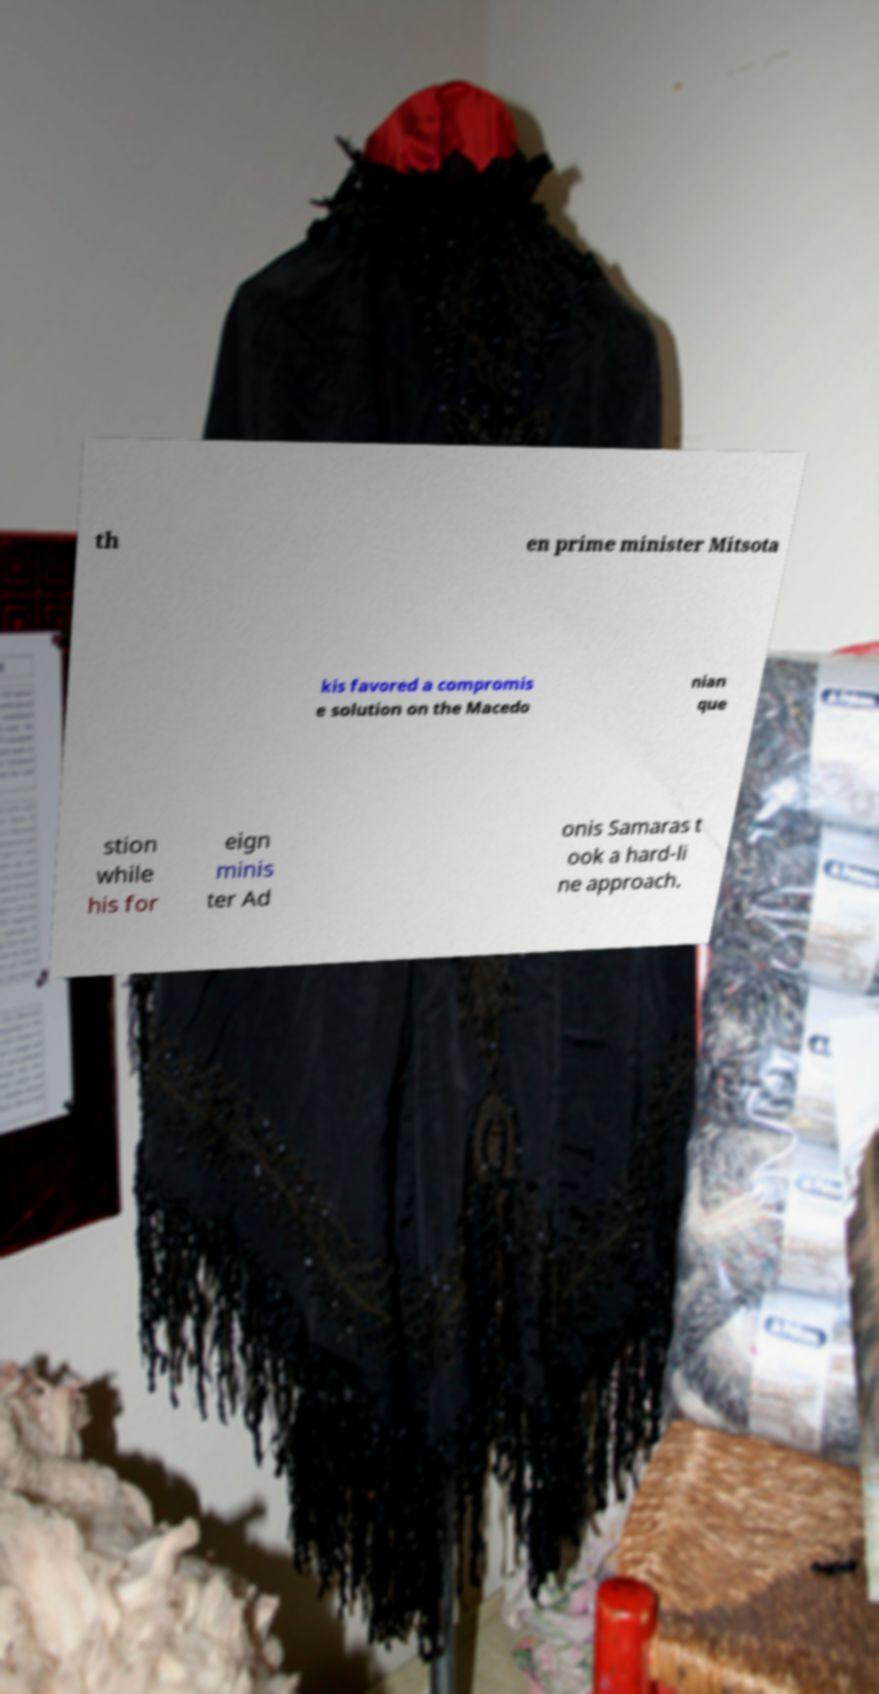What messages or text are displayed in this image? I need them in a readable, typed format. th en prime minister Mitsota kis favored a compromis e solution on the Macedo nian que stion while his for eign minis ter Ad onis Samaras t ook a hard-li ne approach. 